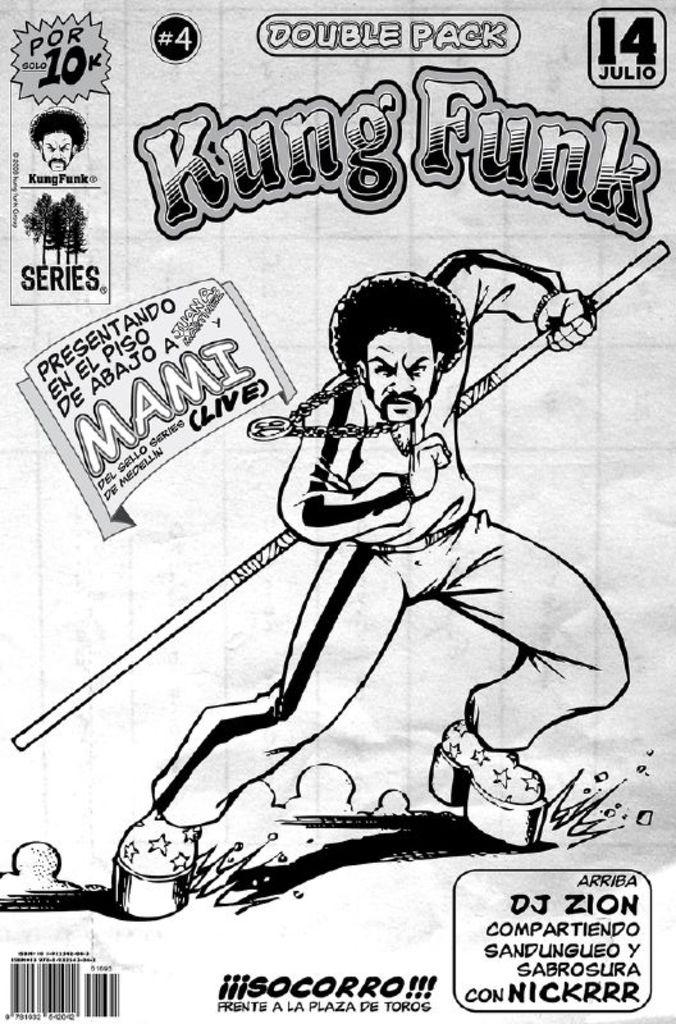What is the main object in the image? There is a poster in the image. What is depicted on the poster? There is a man in the middle of the poster, and he is holding a stick. What can be found at the bottom of the poster? There is text and a barcode at the bottom of the poster. What is present at the top of the poster? There is text, a face, and trees at the top of the poster. How many pigs are visible in the image? There are no pigs present in the image; it features a poster with a man, text, a barcode, a face, and trees. 